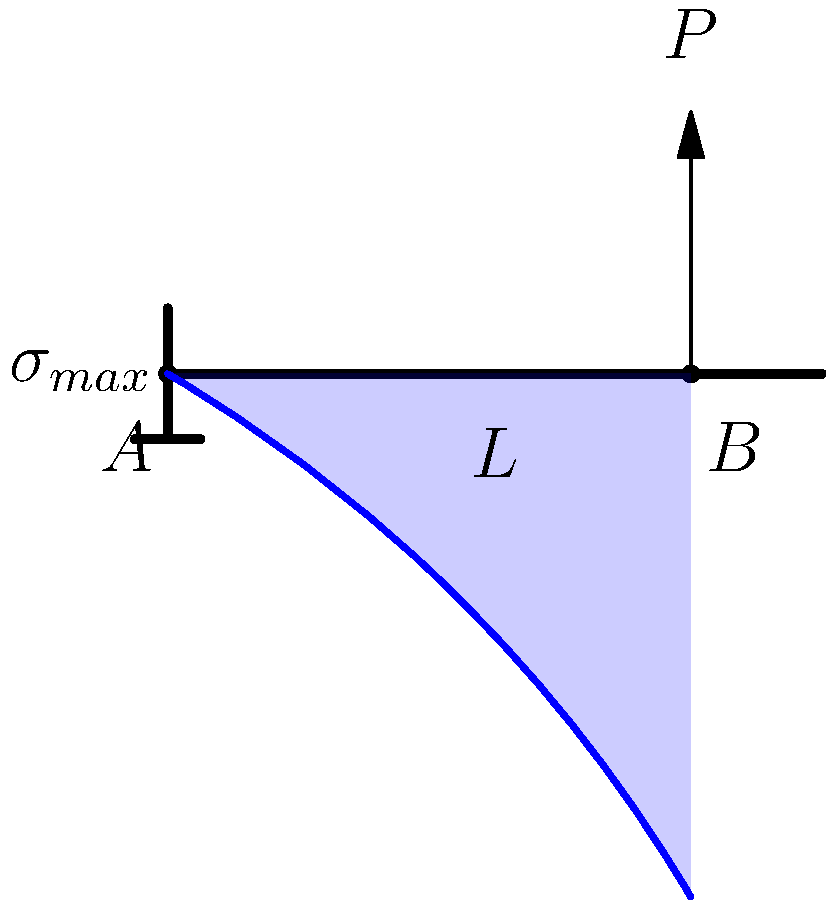As the leader seeking collaboration between neighboring ethnic groups, you're working on a joint engineering project. A cantilever beam of length $L$ is fixed at one end and subjected to a point load $P$ at a distance of $0.8L$ from the fixed end. Describe the stress distribution along the beam and explain where the maximum stress occurs. How does this stress distribution contribute to the overall structural integrity of the project? To understand the stress distribution in this cantilever beam:

1. Beam configuration:
   - Fixed at end A (left)
   - Point load P applied at point B (0.8L from A)

2. Bending moment:
   - Varies linearly along the beam
   - Maximum at the fixed end (A): $M_{max} = PL$
   - Zero at the free end

3. Stress distribution:
   - Follows the bending moment distribution
   - Varies linearly across the beam's cross-section
   - Maximum stress occurs at the outermost fibers

4. Stress equation:
   $$\sigma = \frac{My}{I}$$
   Where:
   - $M$ is the bending moment
   - $y$ is the distance from the neutral axis
   - $I$ is the moment of inertia of the cross-section

5. Maximum stress location:
   - Occurs at the fixed end (A)
   - At the top and bottom surfaces of the beam

6. Stress variation along the length:
   - Decreases linearly from A to B
   - Remains constant from B to the free end

7. Structural integrity implications:
   - The fixed end requires the strongest support
   - Material selection and cross-section design are crucial at the fixed end
   - Gradual stress reduction allows for potential material optimization along the beam

Understanding this stress distribution helps in designing a safe and efficient structure, promoting collaboration by ensuring the project meets the safety standards of all involved ethnic groups.
Answer: Maximum stress occurs at the fixed end (A) on the outermost fibers, decreasing linearly towards the load point (B) and remaining constant thereafter. 